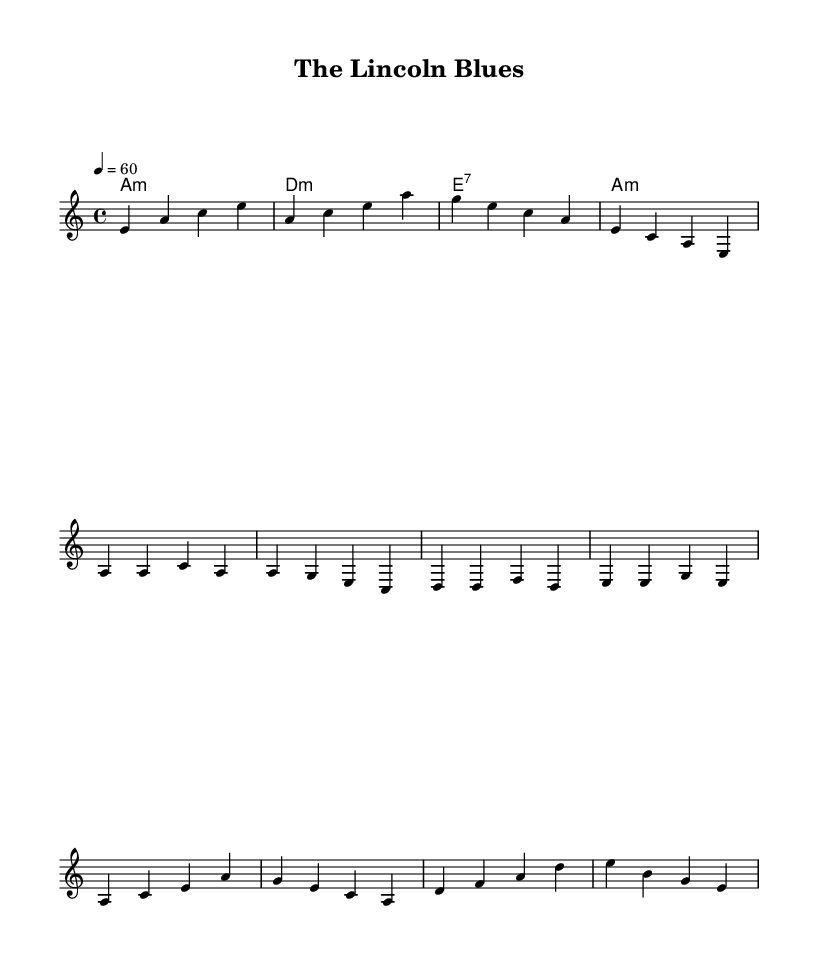What is the key signature of this music? The key signature is indicated at the beginning of the sheet music, which shows it is in A minor. This can be confirmed by looking for the absence of sharps or flats in the signature section.
Answer: A minor What is the time signature of this music? The time signature is found at the beginning of the score alongside the key signature. It shows a 4/4 time signature, meaning there are four beats in a measure and each quarter note gets one beat.
Answer: 4/4 What is the tempo marking for this piece? The tempo marking is also located in the header of the sheet music. It specifies a tempo of 60 beats per minute, which indicates the speed at which the piece should be played.
Answer: 60 How many measures are in the verse section? The verse section is composed of four lines of music, and each line has four measures. By multiplying, we find there are a total of 16 measures in the verse section.
Answer: 16 What is the first lyric in the chorus? The first line of the chorus starts with "Oh," which can be found by referring to the lyrics categorized under the chorus section in the sheet music.
Answer: Oh What is the harmonic progression used in the chorus? To determine the harmonic progression, one must look at the chord symbols that accompany the chorus lyric lines. The progression follows: D minor, F major, A major, and E minor, indicating common chord movement found in blues styles.
Answer: D minor, F major, A major, E minor What is the structural form of the song? The structure can be discerned by analyzing the layout of lyrics and the repeating nature of verses and choruses. The presence of verses followed by repeated choruses indicates a common AAB form typical in Blues music.
Answer: AAB 